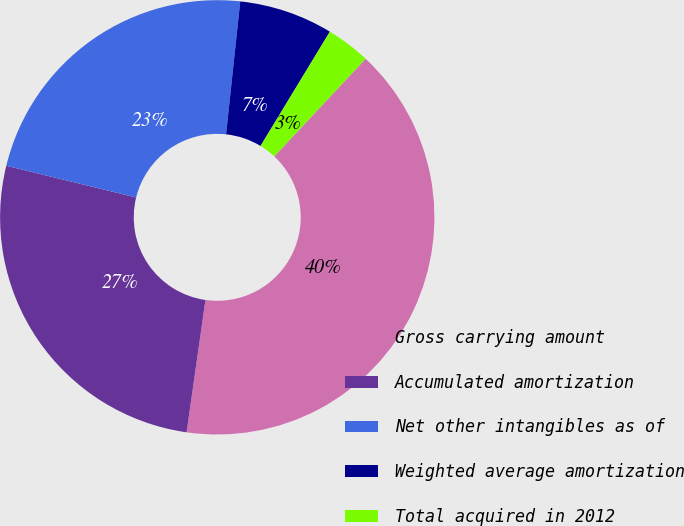Convert chart to OTSL. <chart><loc_0><loc_0><loc_500><loc_500><pie_chart><fcel>Gross carrying amount<fcel>Accumulated amortization<fcel>Net other intangibles as of<fcel>Weighted average amortization<fcel>Total acquired in 2012<nl><fcel>40.28%<fcel>26.56%<fcel>22.87%<fcel>6.99%<fcel>3.29%<nl></chart> 